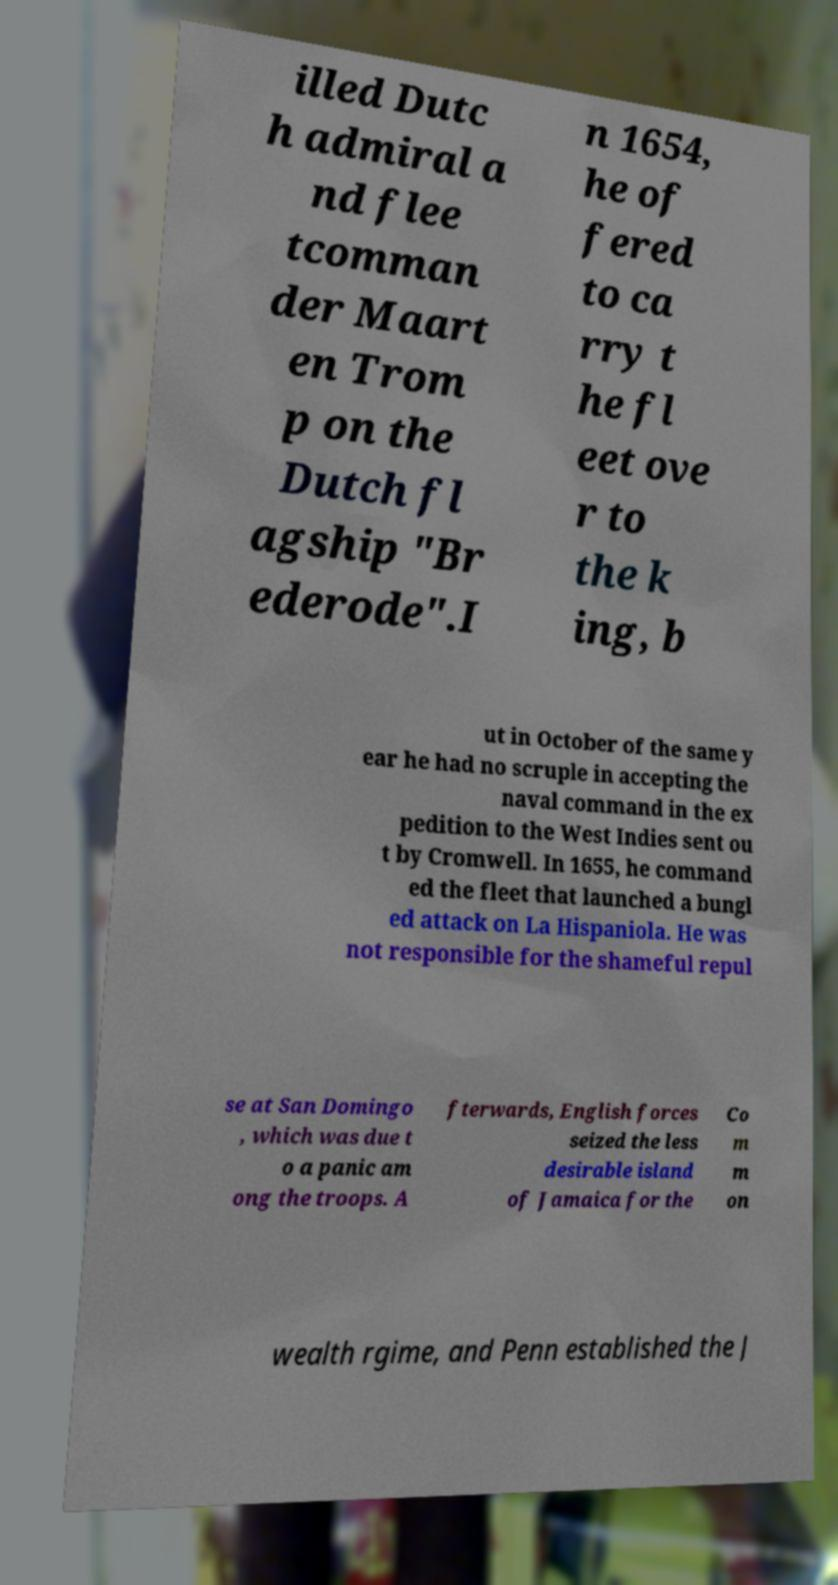What messages or text are displayed in this image? I need them in a readable, typed format. illed Dutc h admiral a nd flee tcomman der Maart en Trom p on the Dutch fl agship "Br ederode".I n 1654, he of fered to ca rry t he fl eet ove r to the k ing, b ut in October of the same y ear he had no scruple in accepting the naval command in the ex pedition to the West Indies sent ou t by Cromwell. In 1655, he command ed the fleet that launched a bungl ed attack on La Hispaniola. He was not responsible for the shameful repul se at San Domingo , which was due t o a panic am ong the troops. A fterwards, English forces seized the less desirable island of Jamaica for the Co m m on wealth rgime, and Penn established the J 